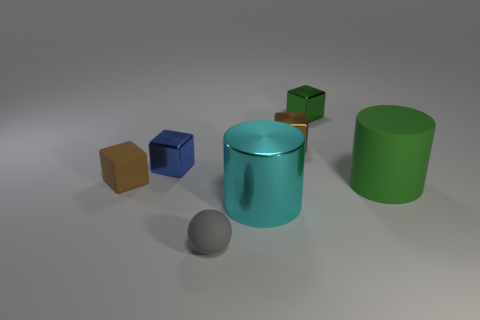There is another large thing that is made of the same material as the blue object; what is its color?
Keep it short and to the point. Cyan. What number of gray matte spheres are in front of the gray rubber ball?
Ensure brevity in your answer.  0. There is a shiny thing in front of the small matte cube; is it the same color as the cylinder behind the shiny cylinder?
Provide a succinct answer. No. What color is the matte object that is the same shape as the big shiny thing?
Your response must be concise. Green. Are there any other things that are the same shape as the gray object?
Your answer should be compact. No. There is a green object behind the blue metal cube; does it have the same shape as the shiny object that is to the left of the tiny gray object?
Your answer should be compact. Yes. Does the cyan metal thing have the same size as the metallic cube on the left side of the large cyan metallic object?
Provide a short and direct response. No. Is the number of small blue metal objects greater than the number of tiny shiny blocks?
Keep it short and to the point. No. Are the small thing that is in front of the cyan shiny cylinder and the tiny brown object left of the brown metal cube made of the same material?
Ensure brevity in your answer.  Yes. What is the blue object made of?
Offer a very short reply. Metal. 